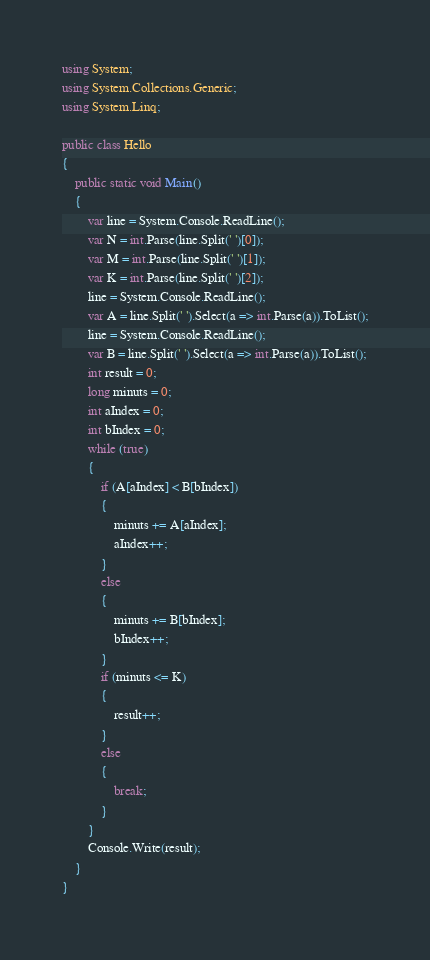Convert code to text. <code><loc_0><loc_0><loc_500><loc_500><_C#_>using System;
using System.Collections.Generic;
using System.Linq;

public class Hello
{
    public static void Main()
    {
        var line = System.Console.ReadLine();
        var N = int.Parse(line.Split(' ')[0]);
        var M = int.Parse(line.Split(' ')[1]);
        var K = int.Parse(line.Split(' ')[2]);
        line = System.Console.ReadLine();
        var A = line.Split(' ').Select(a => int.Parse(a)).ToList();
        line = System.Console.ReadLine();
        var B = line.Split(' ').Select(a => int.Parse(a)).ToList();
        int result = 0;
        long minuts = 0;
        int aIndex = 0;
        int bIndex = 0;
        while (true)
        {
            if (A[aIndex] < B[bIndex])
            {
                minuts += A[aIndex];
                aIndex++;
            }
            else 
            {
                minuts += B[bIndex];
                bIndex++;
            }
            if (minuts <= K)
            {
                result++;
            }
            else
            {
                break;
            }
        }
        Console.Write(result);
    }
}
</code> 